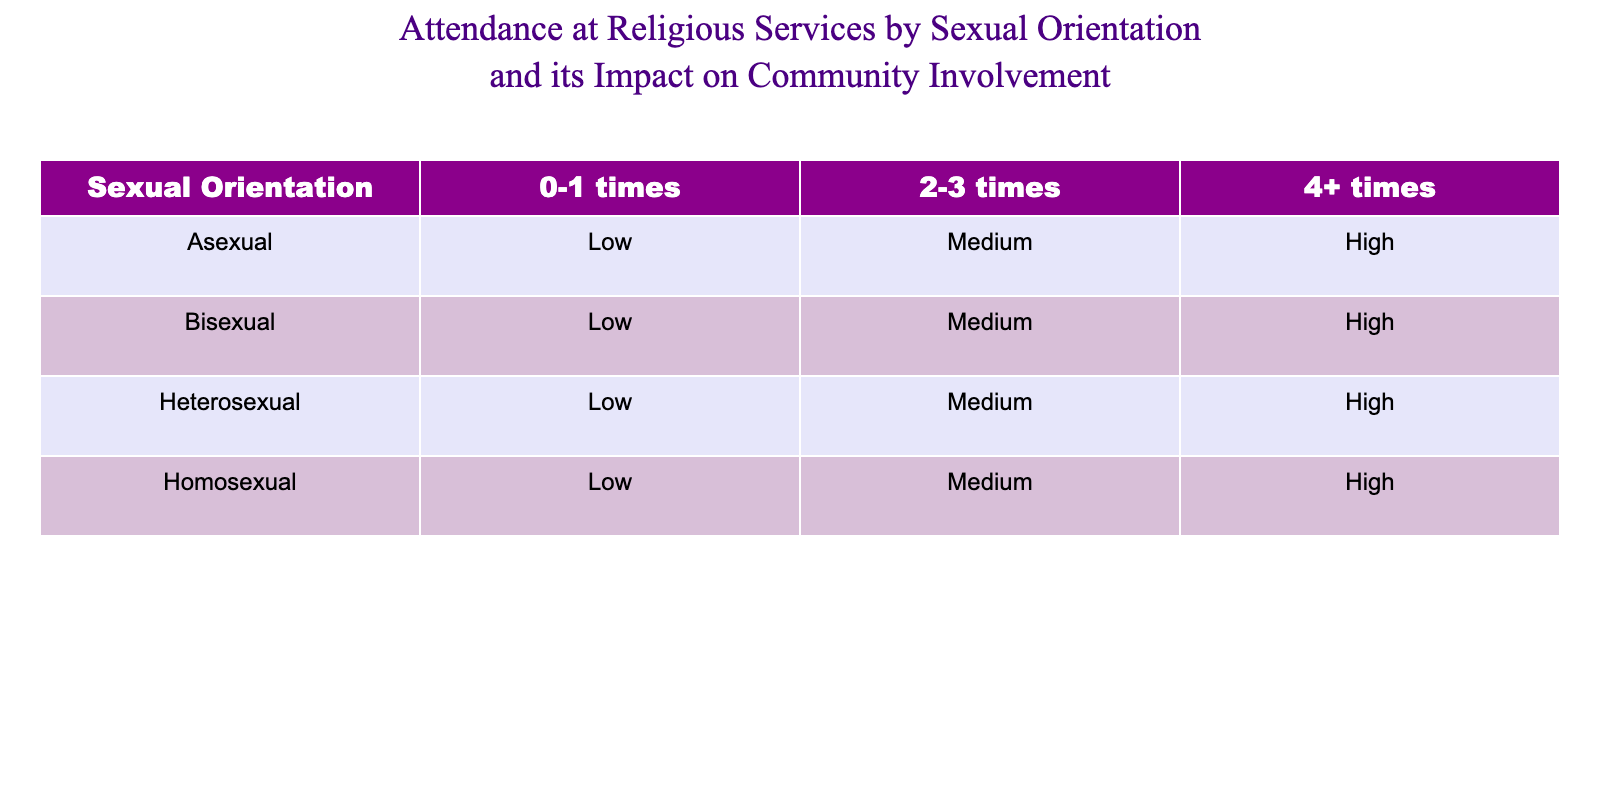What is the community involvement level for Heterosexual individuals who attend services 4 or more times? In the table, we locate the row for Heterosexual individuals and find the column for 4+ times service attendance. In this case, it indicates 'High' involvement.
Answer: High How many sexual orientations have low community involvement for individuals attending religious services 0-1 times? By examining the table, we look at the 0-1 times column and see that both Heterosexual and Homosexual have 'Low' community involvement listed there. Therefore, there are 2 orientations with low involvement.
Answer: 2 Is the community involvement level for Bisexual individuals attending services 2-3 times higher than for those attending 0-1 times? We check the values for Bisexual individuals: 'Medium' for 2-3 times and 'Low' for 0-1 times. Since Medium is higher than Low, the statement is true.
Answer: Yes What is the overall average community involvement level for individuals across all sexual orientations who attend services 4 or more times? We note the community involvement for each sexual orientation in the 4+ times column: High (Heterosexual), High (Homosexual), High (Bisexual), and High (Asexual). Since all values are High, the average community involvement is also High.
Answer: High Does a higher frequency of religious service attendance correlate with higher community involvement across the board? By analyzing the table, we see that for all orientations, as the attendance increases (from 0-1 to 2-3 to 4+), the community involvement consistently goes from Low to Medium to High. This indicates a clear correlation.
Answer: Yes What is the difference in the count of sexual orientations with Medium versus Low community involvement for individuals attending services 2-3 times? For 2-3 times, we identify the Medium involvement levels for Heterosexual, Homosexual, and Bisexual (3 orientations), and we see there is only 1 orientation with Low involvement (Asexual). Thus, the difference is 3 - 1 = 2.
Answer: 2 Are there more sexual orientations represented in the High community involvement category than in the Low category for any service attendance frequency? We examine the High category for 4+ times, which shows Heterosexual, Homosexual, Bisexual, and Asexual (4 orientations) and then look at the Low category for 0-1 times, showing only Heterosexual and Homosexual (2 orientations). Yes, there are more in High.
Answer: Yes How many total sexual orientations have a community involvement level of Medium? From the table, Heterosexual, Homosexual, and Bisexual have Medium involvement at different attendance levels (2-3 times), giving a total of 3 orientations.
Answer: 3 